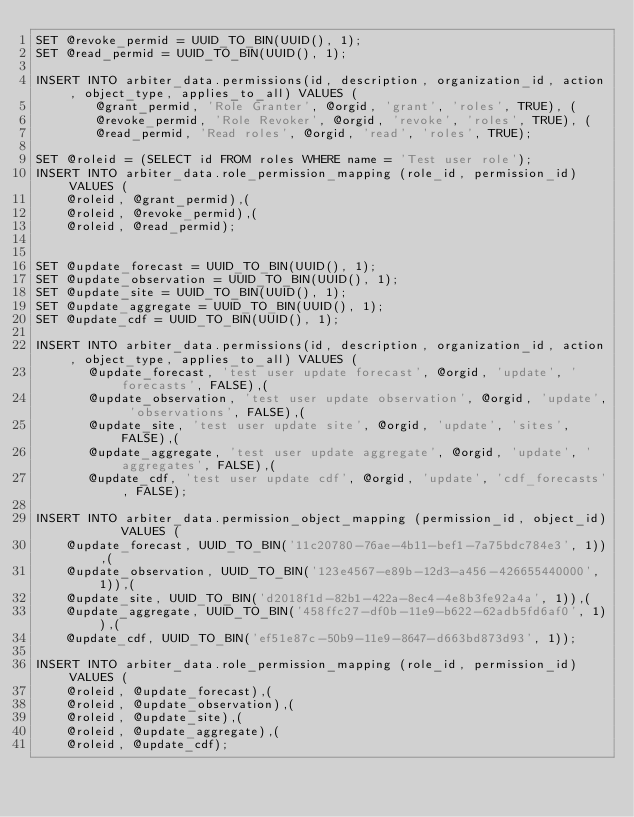Convert code to text. <code><loc_0><loc_0><loc_500><loc_500><_SQL_>SET @revoke_permid = UUID_TO_BIN(UUID(), 1);
SET @read_permid = UUID_TO_BIN(UUID(), 1);

INSERT INTO arbiter_data.permissions(id, description, organization_id, action, object_type, applies_to_all) VALUES (
        @grant_permid, 'Role Granter', @orgid, 'grant', 'roles', TRUE), (
        @revoke_permid, 'Role Revoker', @orgid, 'revoke', 'roles', TRUE), (
        @read_permid, 'Read roles', @orgid, 'read', 'roles', TRUE);
        
SET @roleid = (SELECT id FROM roles WHERE name = 'Test user role');
INSERT INTO arbiter_data.role_permission_mapping (role_id, permission_id) VALUES (
    @roleid, @grant_permid),(
    @roleid, @revoke_permid),(
    @roleid, @read_permid);


SET @update_forecast = UUID_TO_BIN(UUID(), 1);
SET @update_observation = UUID_TO_BIN(UUID(), 1);
SET @update_site = UUID_TO_BIN(UUID(), 1);
SET @update_aggregate = UUID_TO_BIN(UUID(), 1);
SET @update_cdf = UUID_TO_BIN(UUID(), 1);

INSERT INTO arbiter_data.permissions(id, description, organization_id, action, object_type, applies_to_all) VALUES (
       @update_forecast, 'test user update forecast', @orgid, 'update', 'forecasts', FALSE),(
       @update_observation, 'test user update observation', @orgid, 'update', 'observations', FALSE),(
       @update_site, 'test user update site', @orgid, 'update', 'sites', FALSE),(
       @update_aggregate, 'test user update aggregate', @orgid, 'update', 'aggregates', FALSE),(
       @update_cdf, 'test user update cdf', @orgid, 'update', 'cdf_forecasts', FALSE);
       
INSERT INTO arbiter_data.permission_object_mapping (permission_id, object_id)       VALUES (
    @update_forecast, UUID_TO_BIN('11c20780-76ae-4b11-bef1-7a75bdc784e3', 1)),(
    @update_observation, UUID_TO_BIN('123e4567-e89b-12d3-a456-426655440000', 1)),(
    @update_site, UUID_TO_BIN('d2018f1d-82b1-422a-8ec4-4e8b3fe92a4a', 1)),(
    @update_aggregate, UUID_TO_BIN('458ffc27-df0b-11e9-b622-62adb5fd6af0', 1)),(
    @update_cdf, UUID_TO_BIN('ef51e87c-50b9-11e9-8647-d663bd873d93', 1));
        
INSERT INTO arbiter_data.role_permission_mapping (role_id, permission_id) VALUES (
    @roleid, @update_forecast),(
    @roleid, @update_observation),(
    @roleid, @update_site),(
    @roleid, @update_aggregate),(
    @roleid, @update_cdf);
</code> 